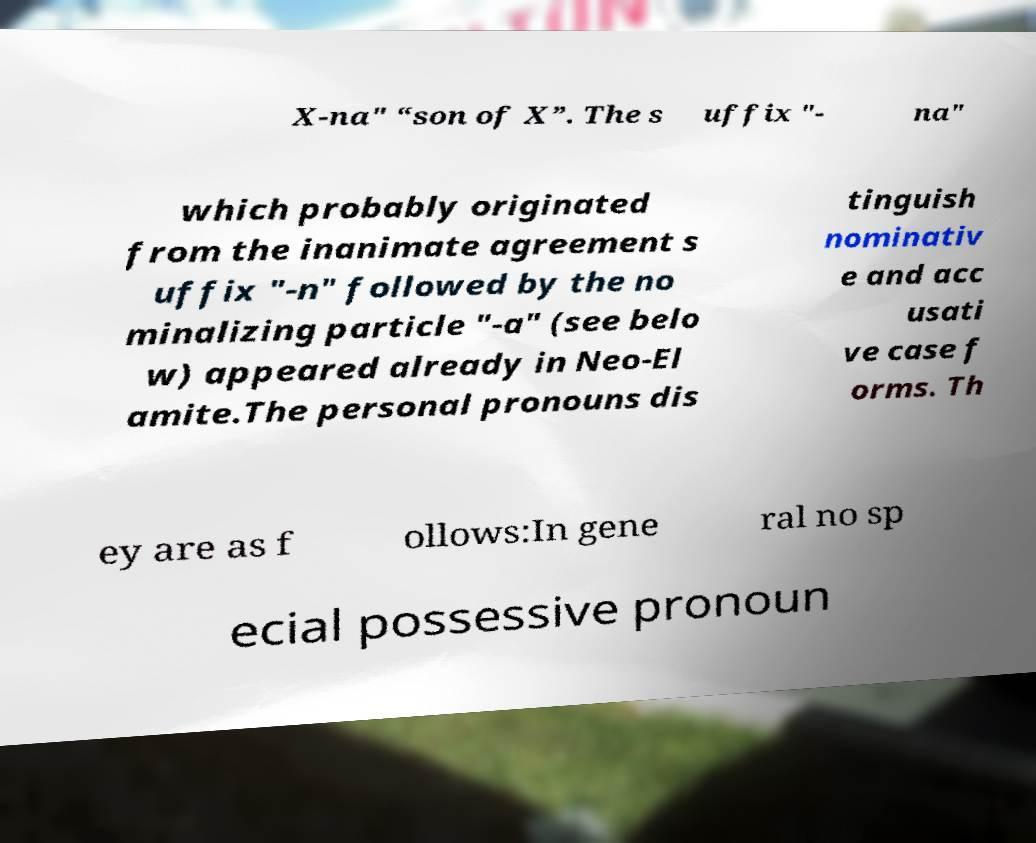Could you extract and type out the text from this image? X-na" “son of X”. The s uffix "- na" which probably originated from the inanimate agreement s uffix "-n" followed by the no minalizing particle "-a" (see belo w) appeared already in Neo-El amite.The personal pronouns dis tinguish nominativ e and acc usati ve case f orms. Th ey are as f ollows:In gene ral no sp ecial possessive pronoun 